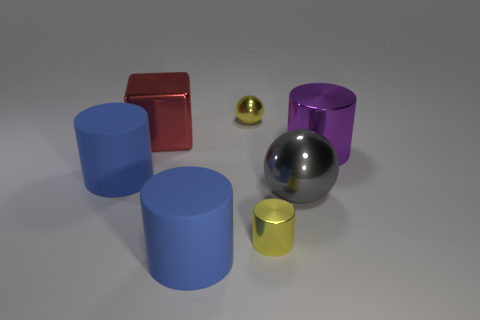Add 3 large yellow objects. How many objects exist? 10 Subtract all cylinders. How many objects are left? 3 Add 3 big purple metallic objects. How many big purple metallic objects are left? 4 Add 3 yellow cylinders. How many yellow cylinders exist? 4 Subtract 0 gray cylinders. How many objects are left? 7 Subtract all big yellow shiny balls. Subtract all red shiny things. How many objects are left? 6 